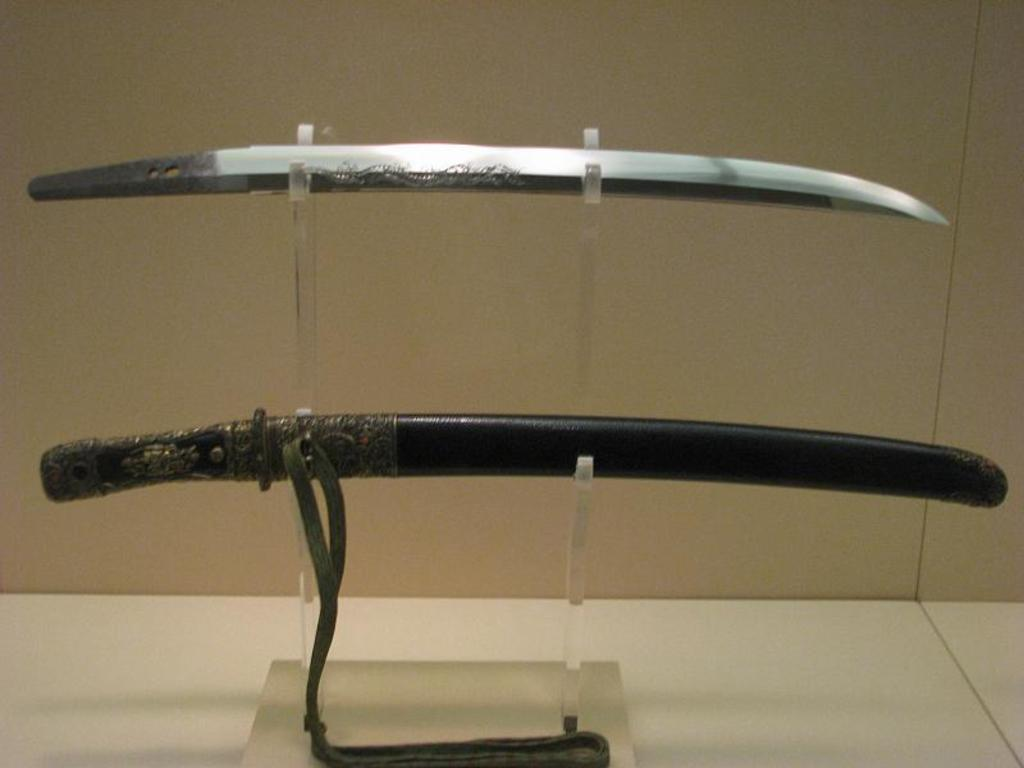What type of weapon is present in the image? There is a sword in the image. Is there any accessory for the sword in the image? Yes, there is a scabbard in the image. How are the sword and scabbard positioned in the image? The sword and scabbard are attached to a stand. Where is the stand with the sword and scabbard located? The stand is placed in a rack. What type of ear is visible on the sword in the image? There is no ear present on the sword in the image. Swords do not have ears as part of their design. 